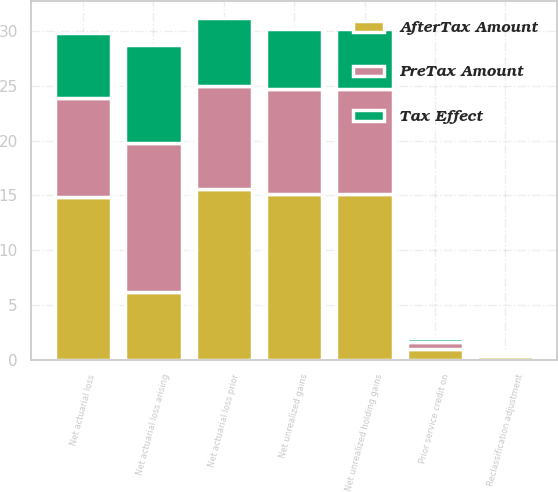Convert chart. <chart><loc_0><loc_0><loc_500><loc_500><stacked_bar_chart><ecel><fcel>Net actuarial loss arising<fcel>Reclassification adjustment<fcel>Net actuarial loss<fcel>Prior service credit on<fcel>Net actuarial loss prior<fcel>Net unrealized holding gains<fcel>Net unrealized gains<nl><fcel>AfterTax Amount<fcel>6.2<fcel>0.3<fcel>14.9<fcel>1<fcel>15.6<fcel>15.1<fcel>15.1<nl><fcel>Tax Effect<fcel>8.9<fcel>0.1<fcel>5.9<fcel>0.4<fcel>6.2<fcel>5.5<fcel>5.5<nl><fcel>PreTax Amount<fcel>13.6<fcel>0.2<fcel>9<fcel>0.6<fcel>9.4<fcel>9.6<fcel>9.6<nl></chart> 